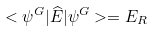Convert formula to latex. <formula><loc_0><loc_0><loc_500><loc_500>< \psi ^ { G } | { \widehat { E } } | \psi ^ { G } > = E _ { R }</formula> 